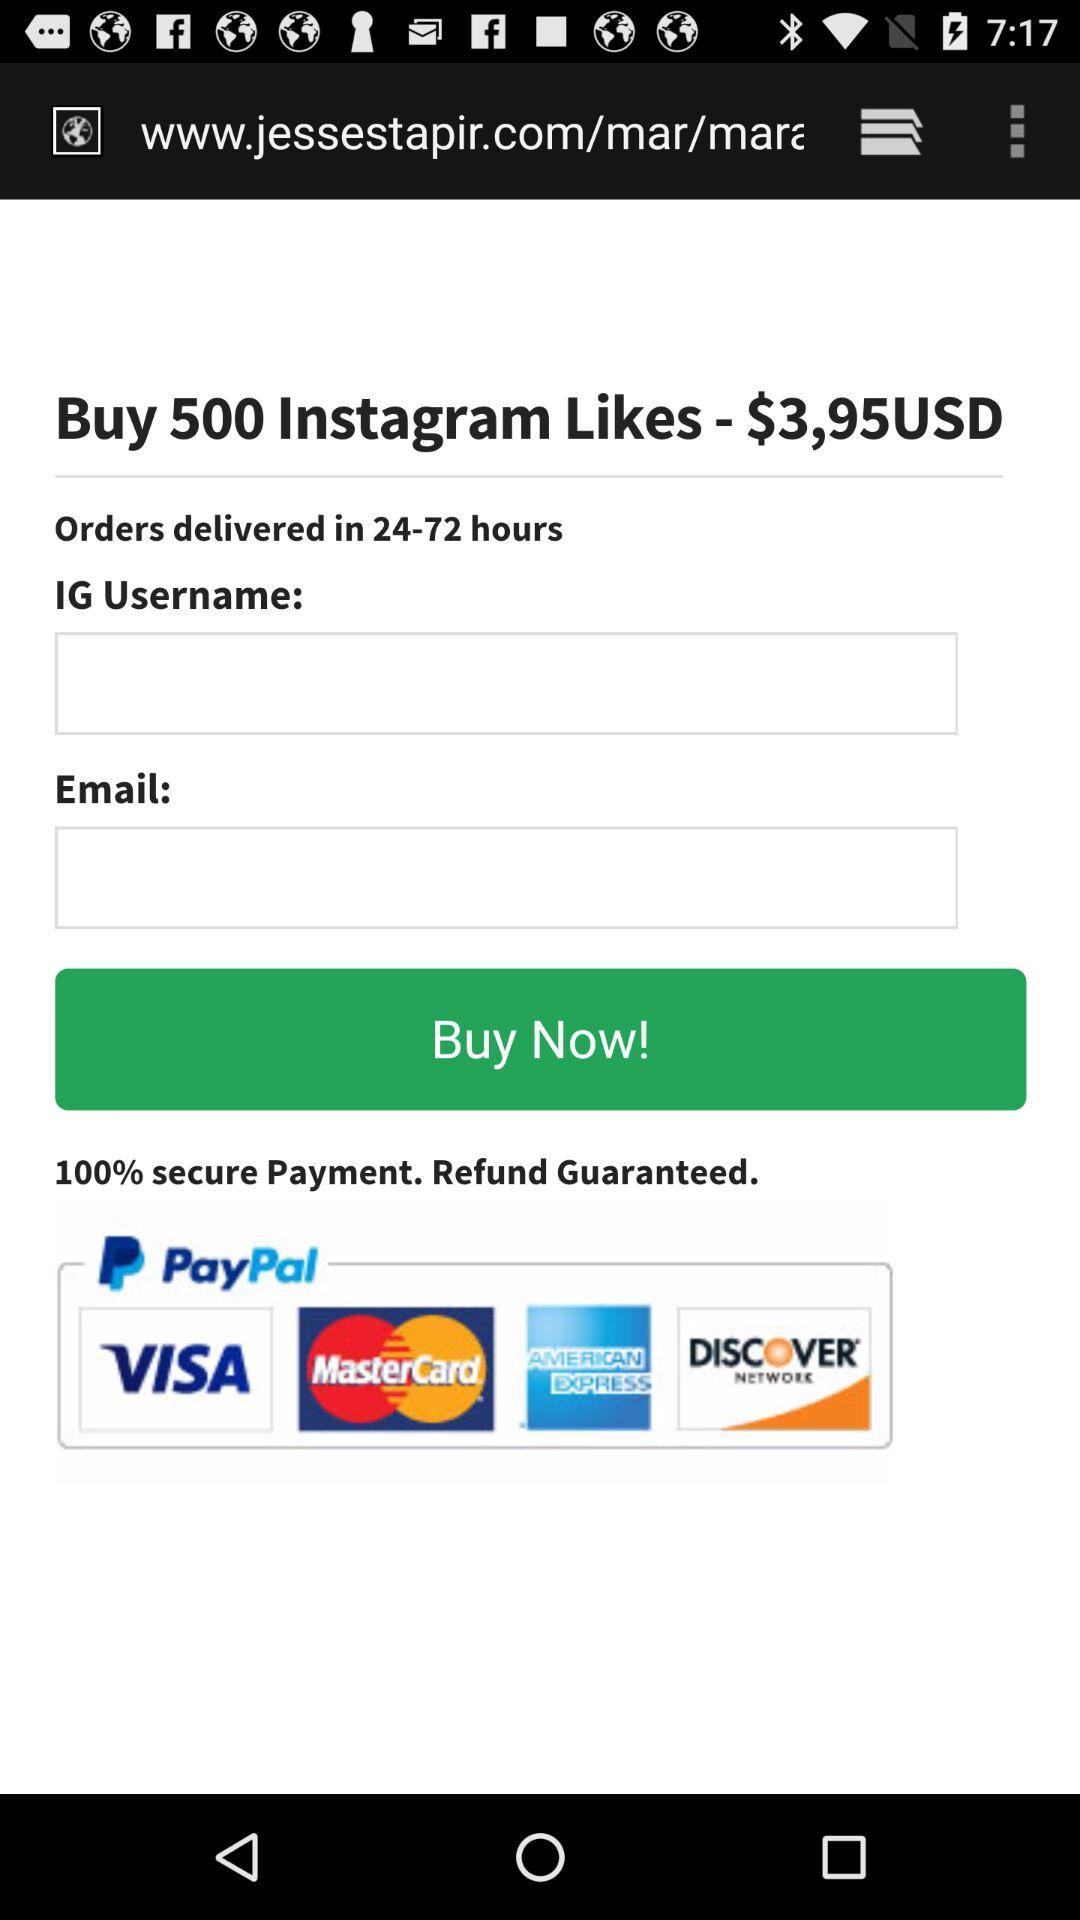How many payment methods are offered?
Answer the question using a single word or phrase. 4 